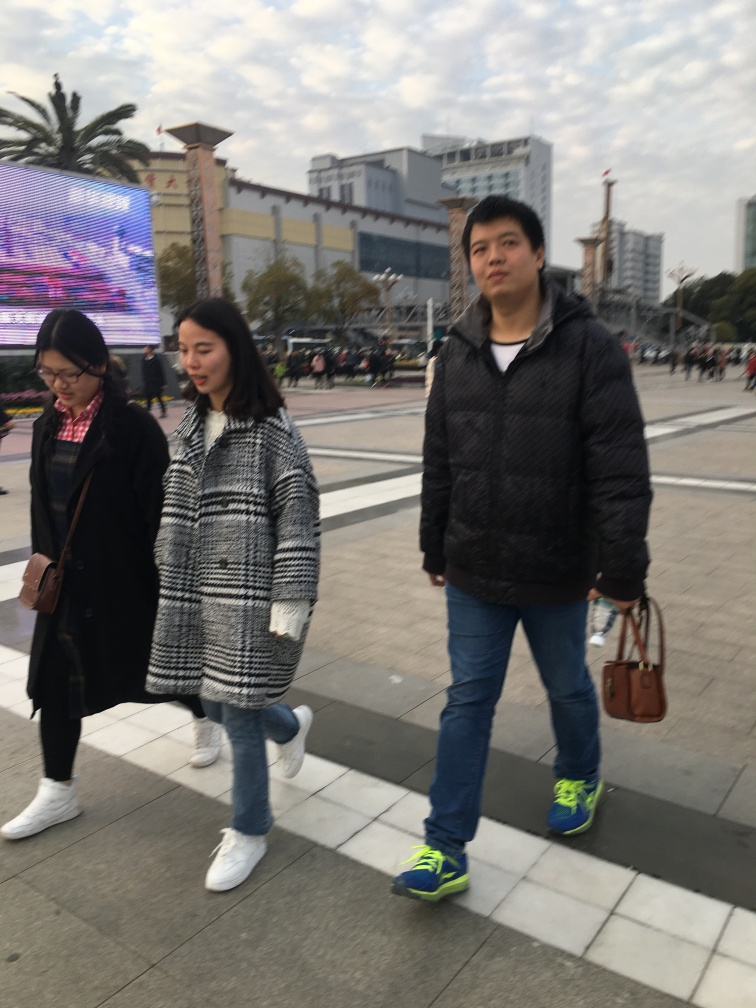What is the mood or atmosphere conveyed by the image, and how do the subjects contribute to it? The mood of the image seems candid and routine, capturing an everyday moment of people walking. The relaxed posture of the individuals, along with the ambient light and urban setting, conveys a sense of daily life and movement within a city. 